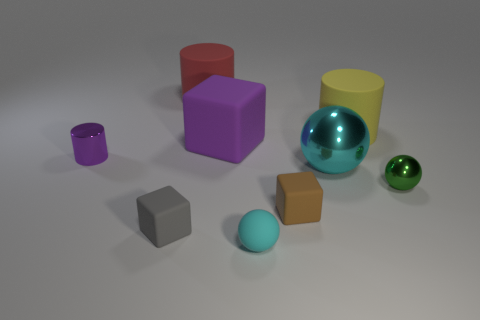Subtract all purple cylinders. Subtract all red balls. How many cylinders are left? 2 Add 1 gray rubber blocks. How many objects exist? 10 Subtract all blocks. How many objects are left? 6 Add 7 small cubes. How many small cubes exist? 9 Subtract 1 gray blocks. How many objects are left? 8 Subtract all metal spheres. Subtract all red rubber things. How many objects are left? 6 Add 8 small cyan matte spheres. How many small cyan matte spheres are left? 9 